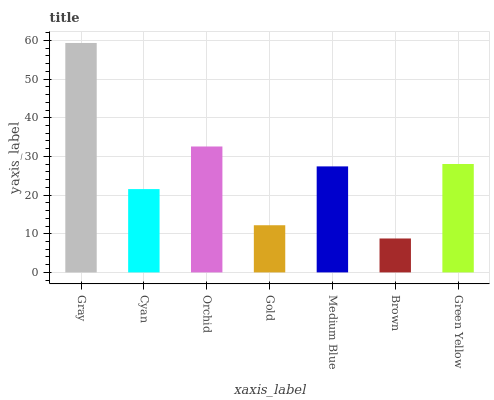Is Brown the minimum?
Answer yes or no. Yes. Is Gray the maximum?
Answer yes or no. Yes. Is Cyan the minimum?
Answer yes or no. No. Is Cyan the maximum?
Answer yes or no. No. Is Gray greater than Cyan?
Answer yes or no. Yes. Is Cyan less than Gray?
Answer yes or no. Yes. Is Cyan greater than Gray?
Answer yes or no. No. Is Gray less than Cyan?
Answer yes or no. No. Is Medium Blue the high median?
Answer yes or no. Yes. Is Medium Blue the low median?
Answer yes or no. Yes. Is Gray the high median?
Answer yes or no. No. Is Green Yellow the low median?
Answer yes or no. No. 